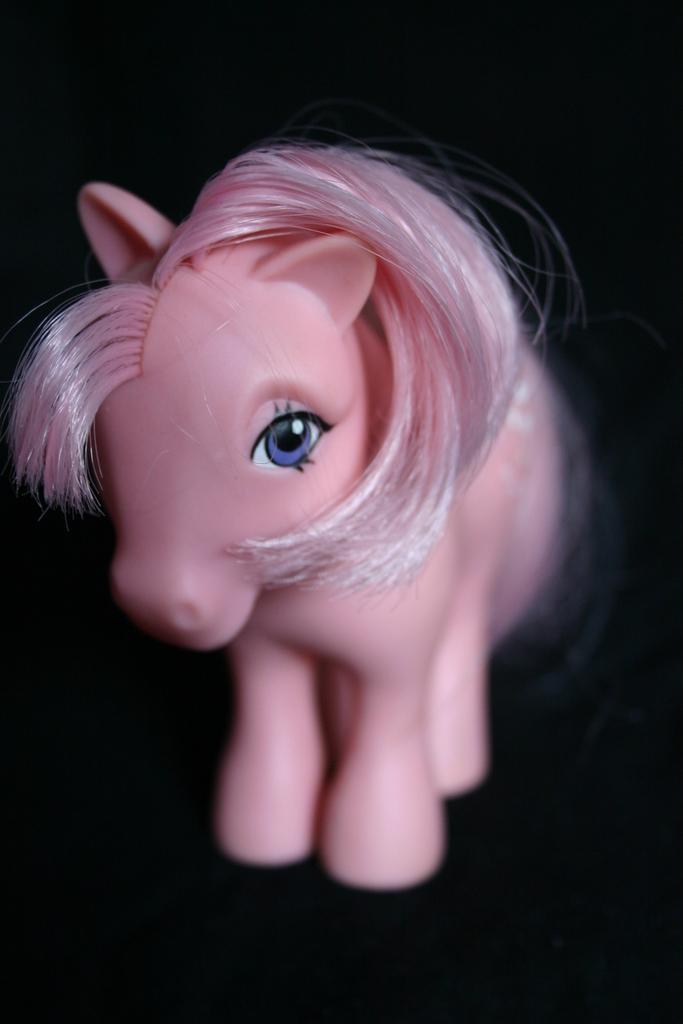In one or two sentences, can you explain what this image depicts? In this image we can see a toy placed on the surface. 